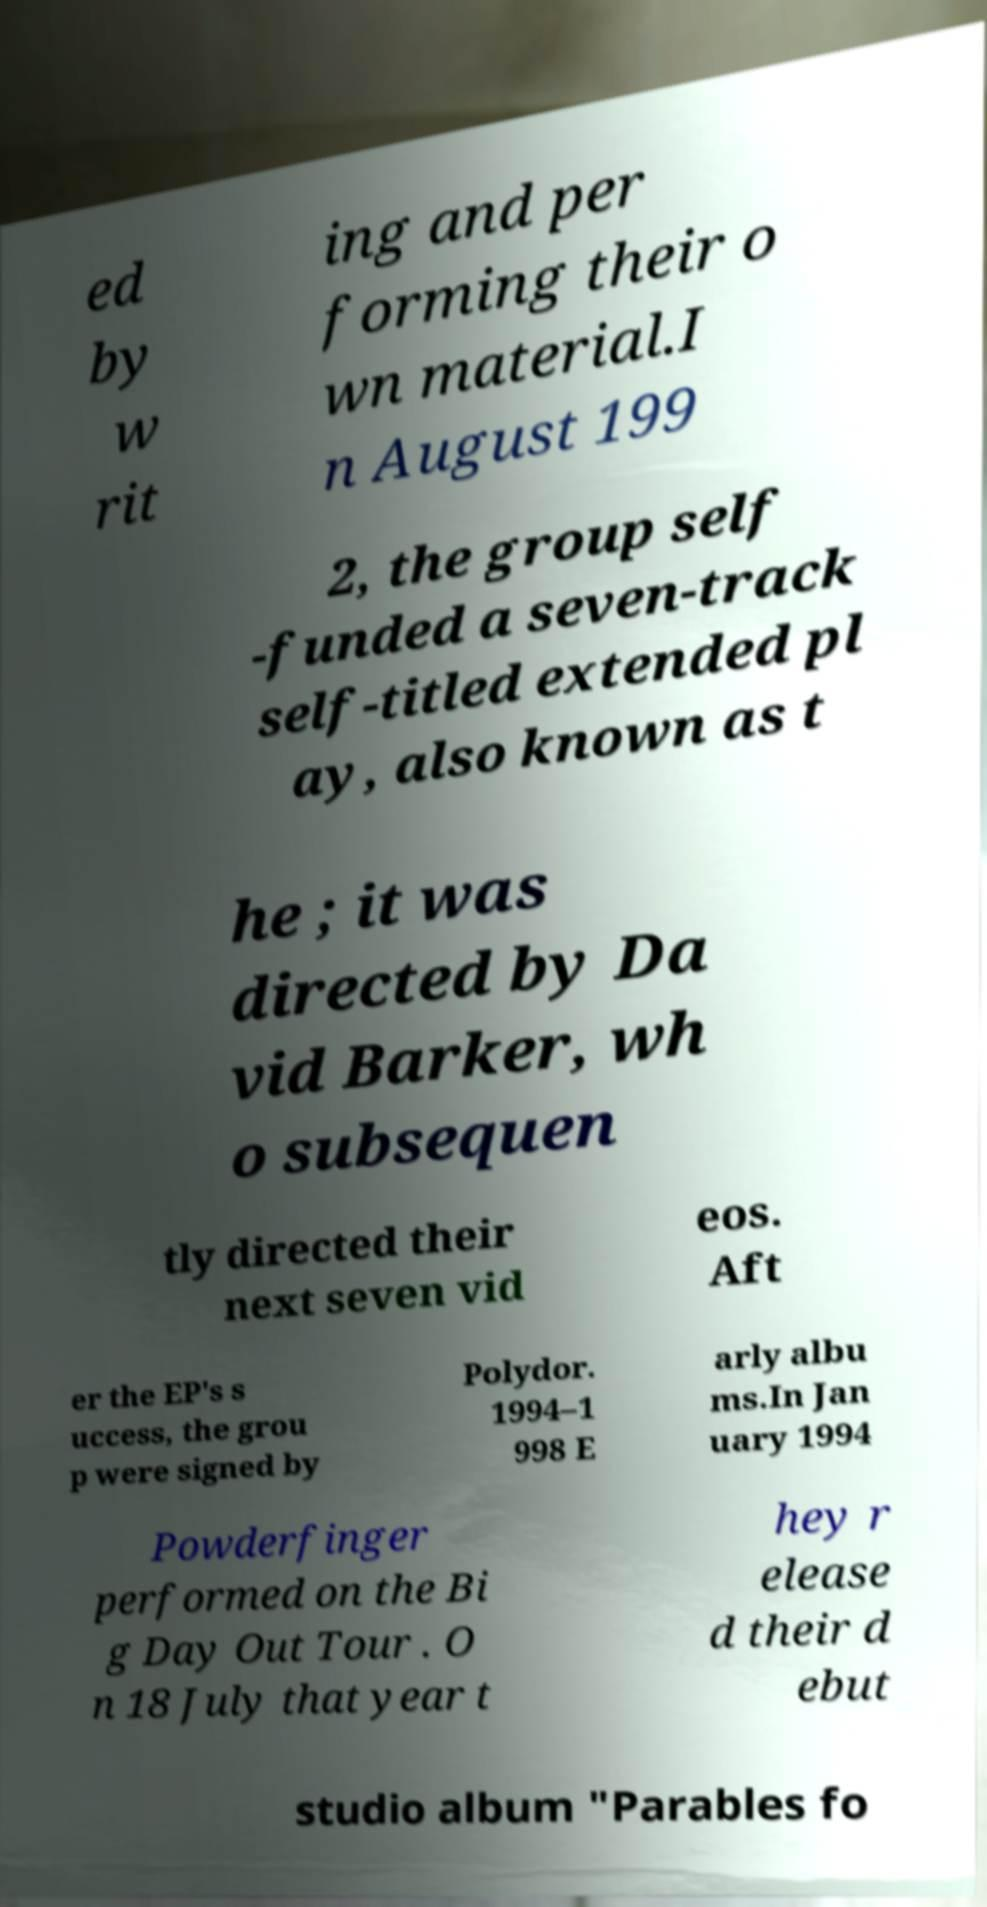Please read and relay the text visible in this image. What does it say? ed by w rit ing and per forming their o wn material.I n August 199 2, the group self -funded a seven-track self-titled extended pl ay, also known as t he ; it was directed by Da vid Barker, wh o subsequen tly directed their next seven vid eos. Aft er the EP's s uccess, the grou p were signed by Polydor. 1994–1 998 E arly albu ms.In Jan uary 1994 Powderfinger performed on the Bi g Day Out Tour . O n 18 July that year t hey r elease d their d ebut studio album "Parables fo 